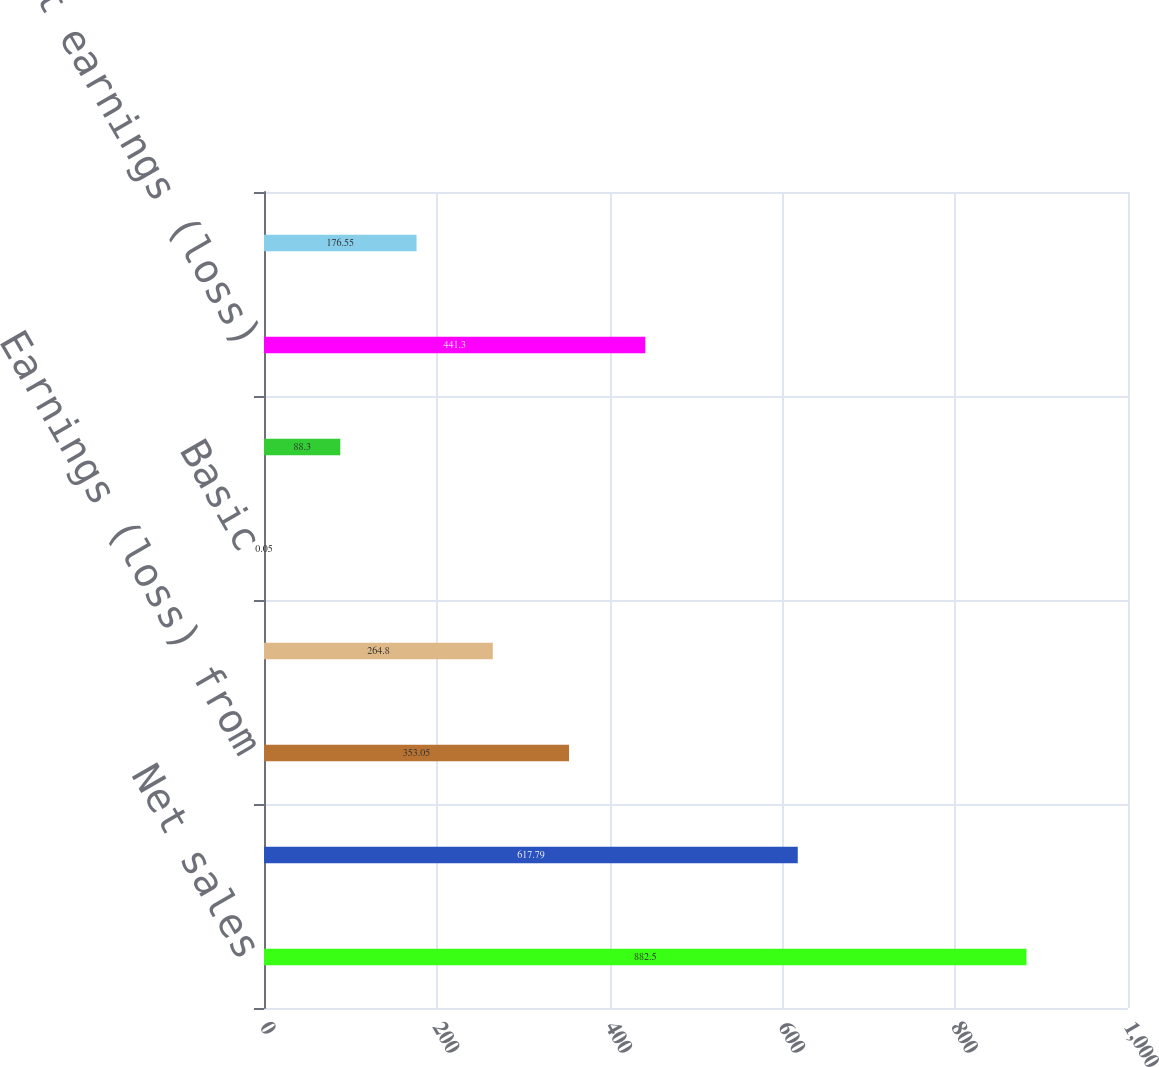Convert chart. <chart><loc_0><loc_0><loc_500><loc_500><bar_chart><fcel>Net sales<fcel>Gross profit<fcel>Earnings (loss) from<fcel>Net earnings (loss) from<fcel>Basic<fcel>Diluted<fcel>Net earnings (loss)<fcel>Earnings (loss) per share from<nl><fcel>882.5<fcel>617.79<fcel>353.05<fcel>264.8<fcel>0.05<fcel>88.3<fcel>441.3<fcel>176.55<nl></chart> 